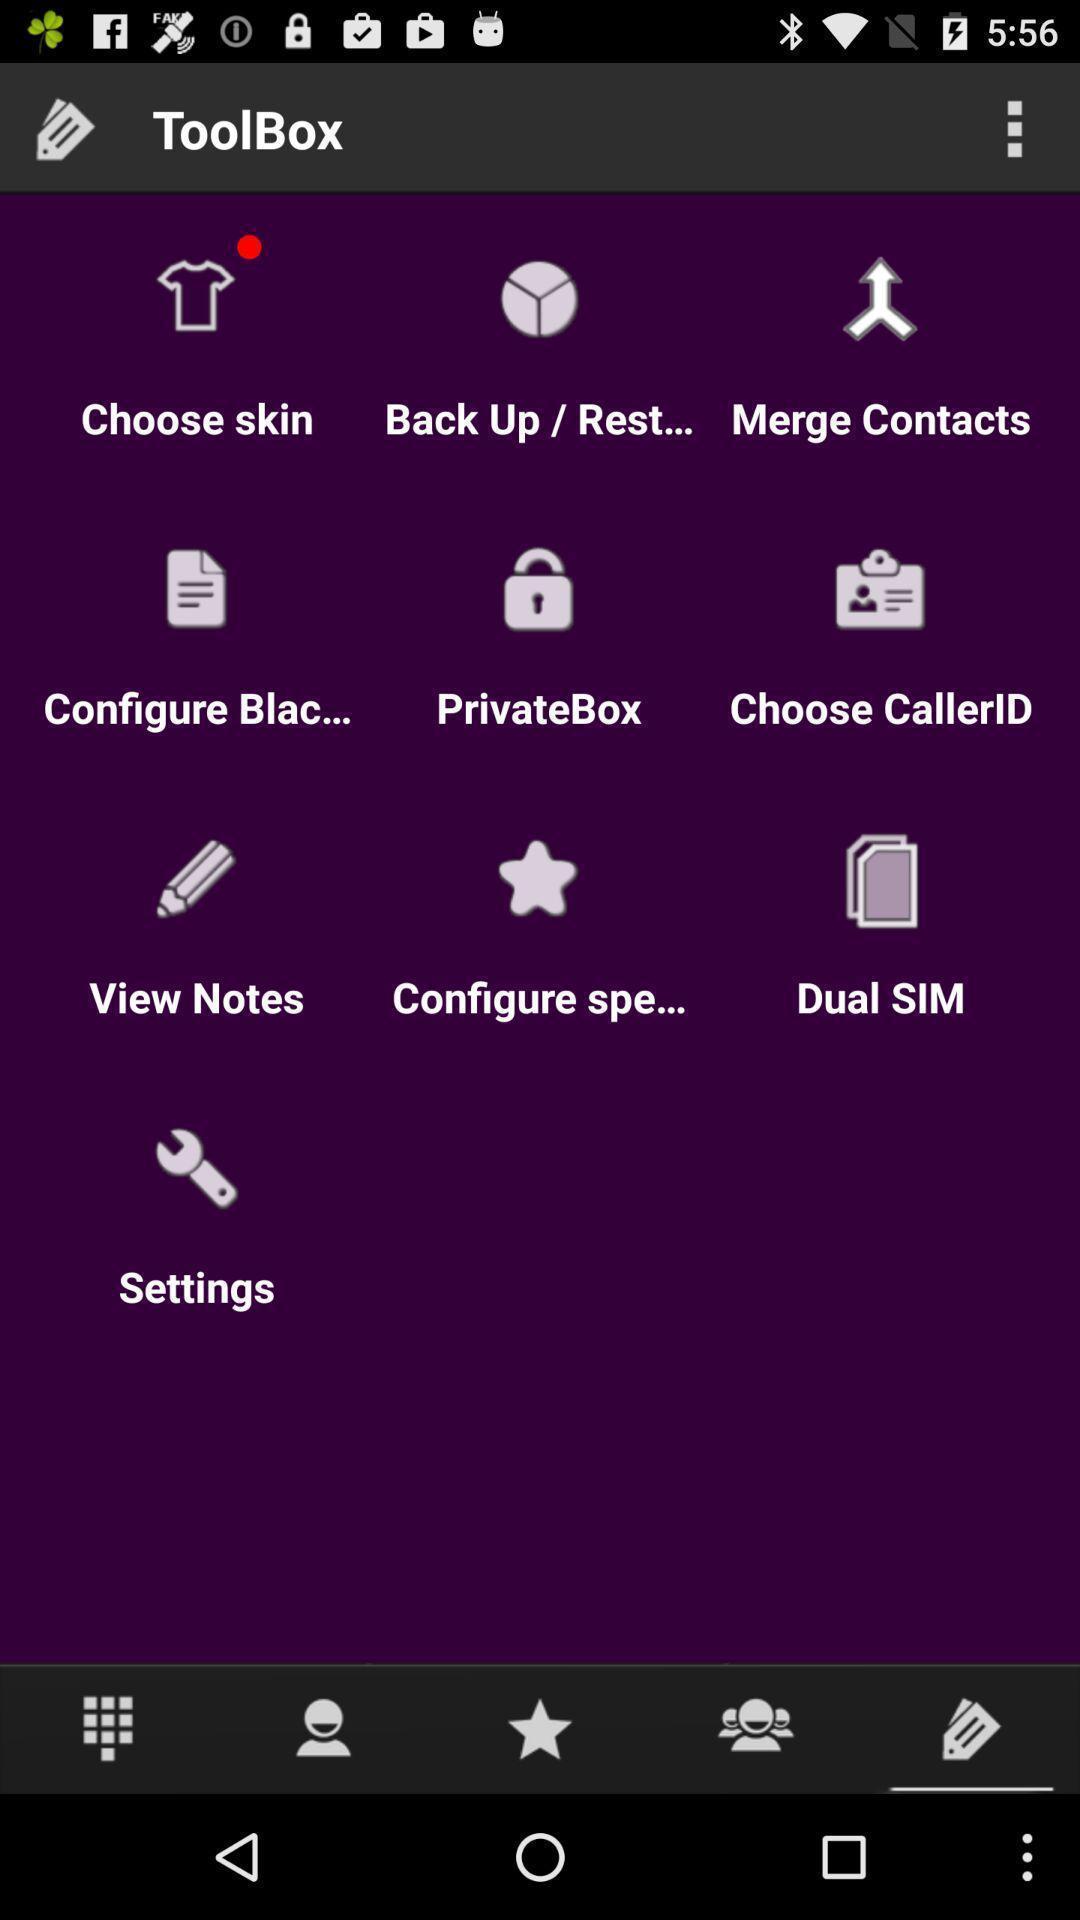What can you discern from this picture? Page displaying various tools. 